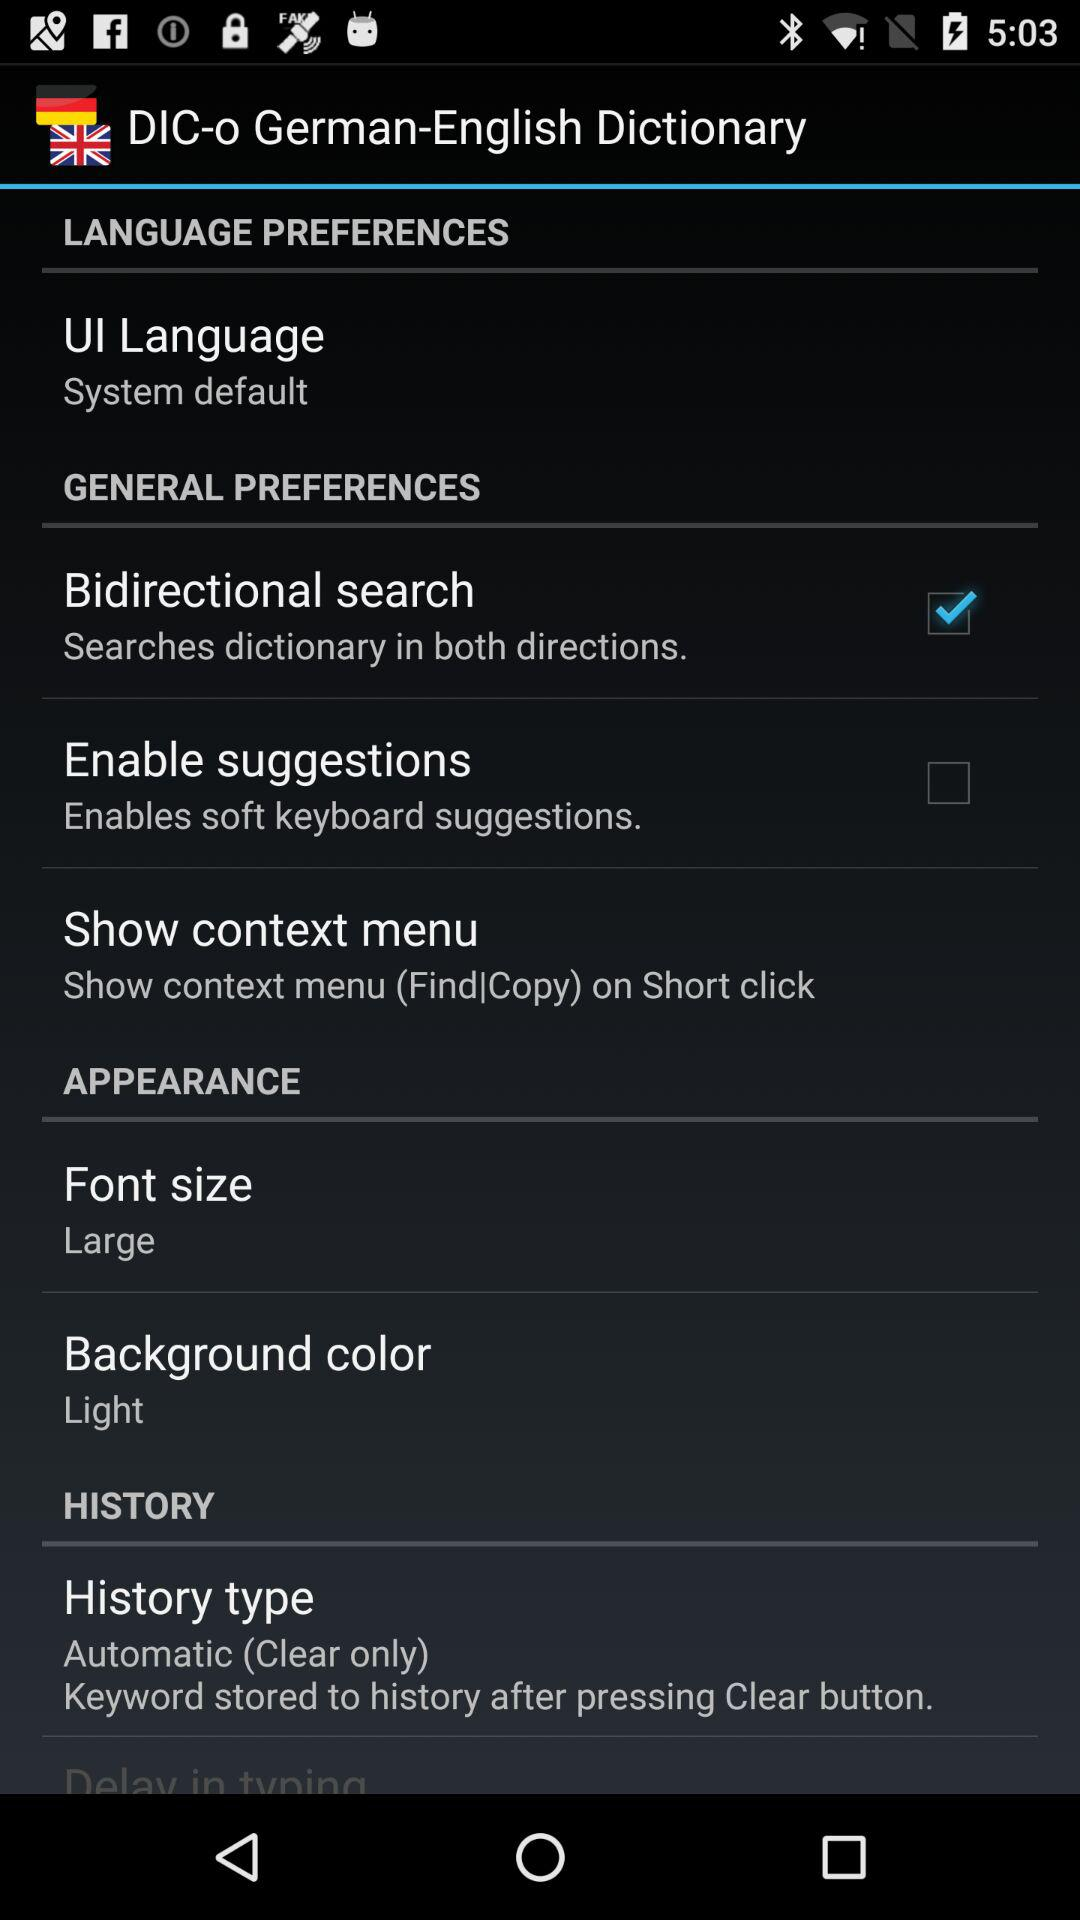What is the application name? The application name is "DIC-o German-English". 